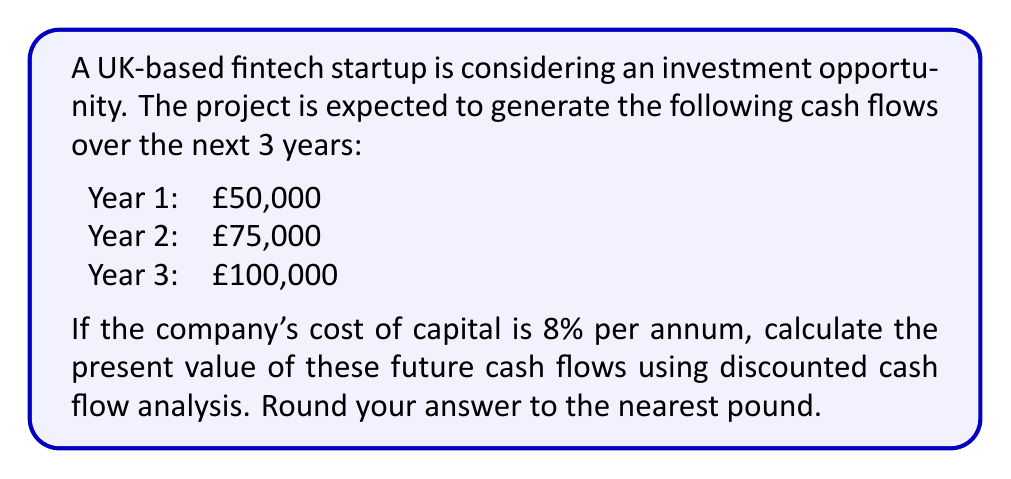Teach me how to tackle this problem. To calculate the present value of future cash flows using discounted cash flow analysis, we need to follow these steps:

1. Identify the future cash flows
2. Determine the discount rate (cost of capital)
3. Calculate the present value of each cash flow
4. Sum up all the present values

Let's go through each step:

1. Future cash flows:
   Year 1: £50,000
   Year 2: £75,000
   Year 3: £100,000

2. Discount rate: 8% per annum

3. Calculate the present value of each cash flow:

   The formula for present value is:
   $$ PV = \frac{FV}{(1 + r)^n} $$
   Where:
   PV = Present Value
   FV = Future Value
   r = Discount rate
   n = Number of periods

   For Year 1: $$ PV_1 = \frac{50,000}{(1 + 0.08)^1} = \frac{50,000}{1.08} = £46,296.30 $$
   
   For Year 2: $$ PV_2 = \frac{75,000}{(1 + 0.08)^2} = \frac{75,000}{1.1664} = £64,300.24 $$
   
   For Year 3: $$ PV_3 = \frac{100,000}{(1 + 0.08)^3} = \frac{100,000}{1.2597} = £79,383.19 $$

4. Sum up all the present values:

   Total Present Value = £46,296.30 + £64,300.24 + £79,383.19 = £189,979.73

Rounding to the nearest pound, we get £189,980.
Answer: £189,980 